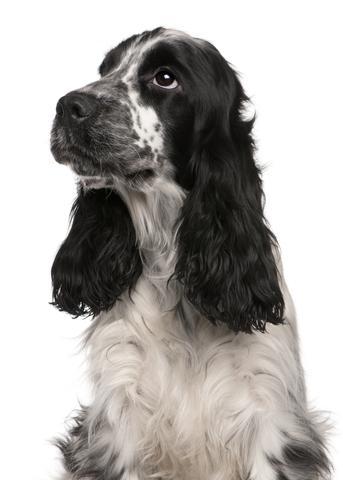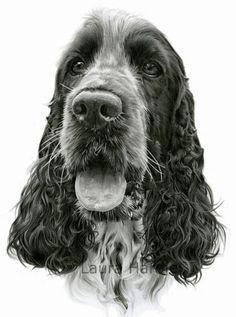The first image is the image on the left, the second image is the image on the right. Examine the images to the left and right. Is the description "An image shows exactly one dog colored dark chocolate brown." accurate? Answer yes or no. No. The first image is the image on the left, the second image is the image on the right. For the images displayed, is the sentence "At least one of the dogs has its tongue handing out." factually correct? Answer yes or no. Yes. 